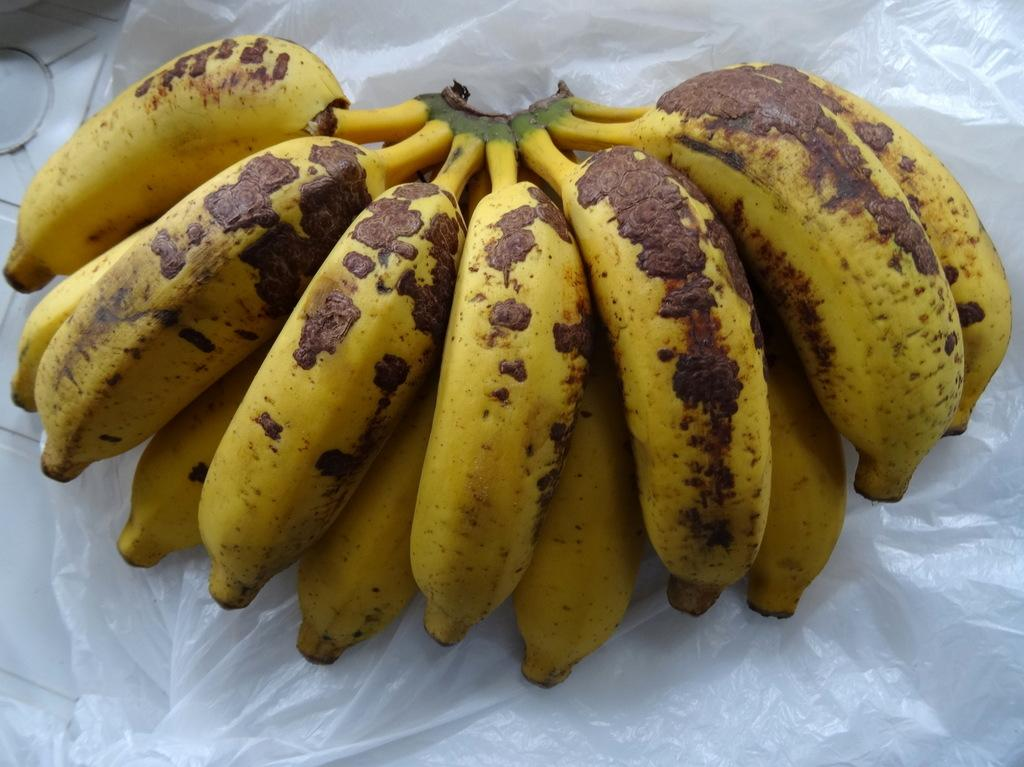What type of fruit is visible in the image? There is a bunch of bananas in the image. What colors are the bananas in the image? The bananas are yellow and brown in color. What is the bananas resting on in the image? The bananas are on a white colored plastic cover. What type of silver object can be seen in the image? There is no silver object present in the image; it only features a bunch of bananas on a white plastic cover. 